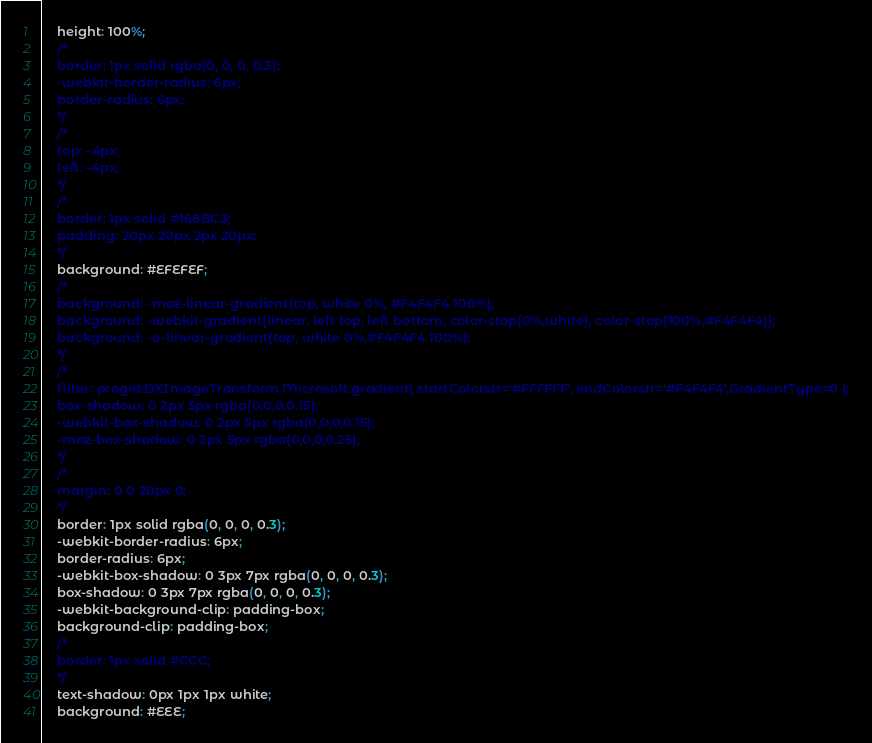Convert code to text. <code><loc_0><loc_0><loc_500><loc_500><_CSS_>	height: 100%;
	/*
	border: 1px solid rgba(0, 0, 0, 0.3);
	-webkit-border-radius: 6px;
	border-radius: 6px;
	*/
	/*
	top: -4px;
	left: -4px;
	*/
	/*
	border: 1px solid #168BC3;
	padding: 20px 20px 2px 20px;
	*/
	background: #EFEFEF;
	/*
	background: -moz-linear-gradient(top, white 0%, #F4F4F4 100%);
	background: -webkit-gradient(linear, left top, left bottom, color-stop(0%,white), color-stop(100%,#F4F4F4));
	background: -o-linear-gradient(top, white 0%,#F4F4F4 100%);
	*/
	/*
	filter: progid:DXImageTransform.Microsoft.gradient( startColorstr='#FFFFFF', endColorstr='#F4F4F4',GradientType=0 );
	box-shadow: 0 2px 5px rgba(0,0,0,0.15);
	-webkit-box-shadow: 0 2px 5px rgba(0,0,0,0.15);
	-moz-box-shadow: 0 2px 5px rgba(0,0,0,0.25);
	*/
	/*
	margin: 0 0 20px 0;
	*/
	border: 1px solid rgba(0, 0, 0, 0.3);
	-webkit-border-radius: 6px;
	border-radius: 6px;
	-webkit-box-shadow: 0 3px 7px rgba(0, 0, 0, 0.3);
	box-shadow: 0 3px 7px rgba(0, 0, 0, 0.3);
	-webkit-background-clip: padding-box;
	background-clip: padding-box;
	/*
	border: 1px solid #CCC;
	*/
	text-shadow: 0px 1px 1px white;
	background: #EEE;</code> 